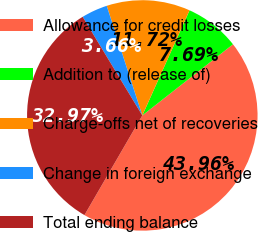<chart> <loc_0><loc_0><loc_500><loc_500><pie_chart><fcel>Allowance for credit losses<fcel>Addition to (release of)<fcel>Charge-offs net of recoveries<fcel>Change in foreign exchange<fcel>Total ending balance<nl><fcel>43.96%<fcel>7.69%<fcel>11.72%<fcel>3.66%<fcel>32.97%<nl></chart> 